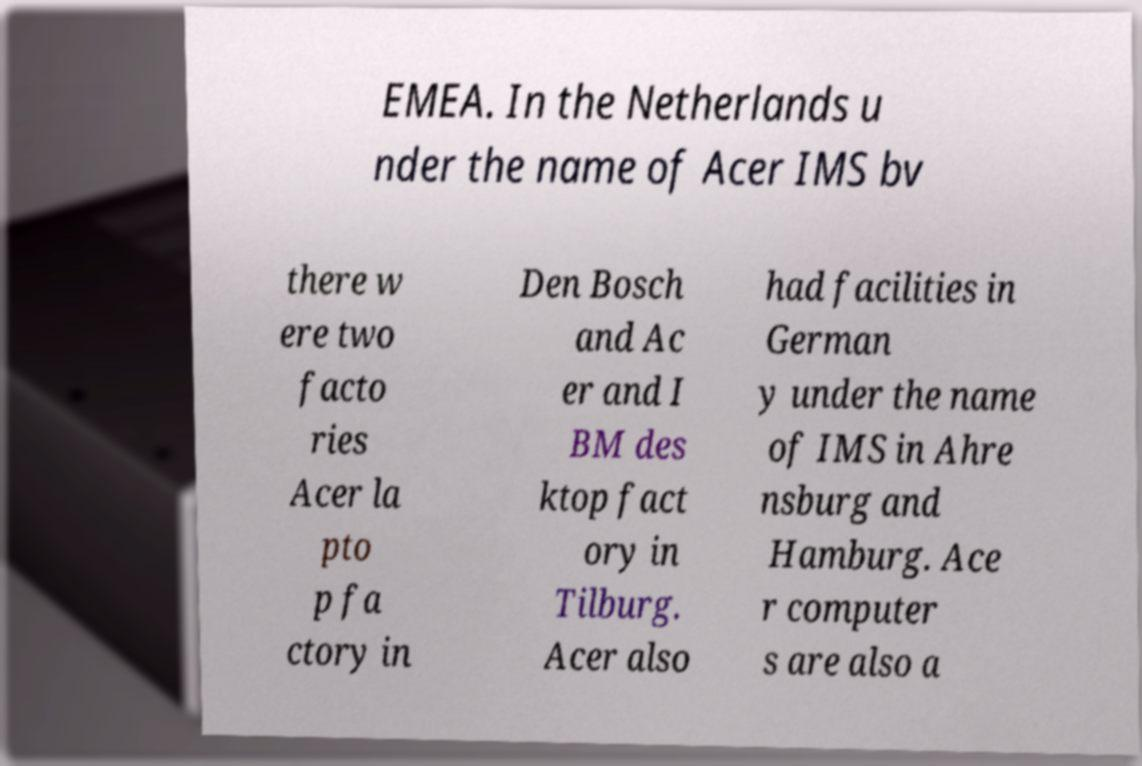For documentation purposes, I need the text within this image transcribed. Could you provide that? EMEA. In the Netherlands u nder the name of Acer IMS bv there w ere two facto ries Acer la pto p fa ctory in Den Bosch and Ac er and I BM des ktop fact ory in Tilburg. Acer also had facilities in German y under the name of IMS in Ahre nsburg and Hamburg. Ace r computer s are also a 